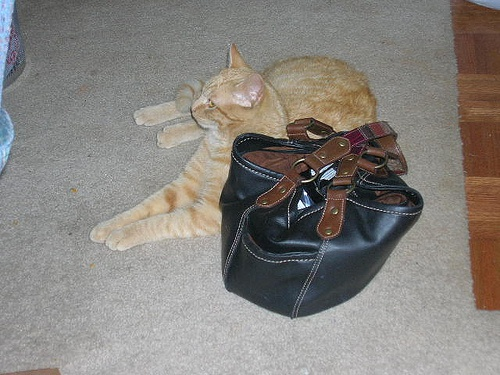Describe the objects in this image and their specific colors. I can see handbag in lightblue, black, gray, and maroon tones and cat in lightblue, darkgray, tan, and gray tones in this image. 